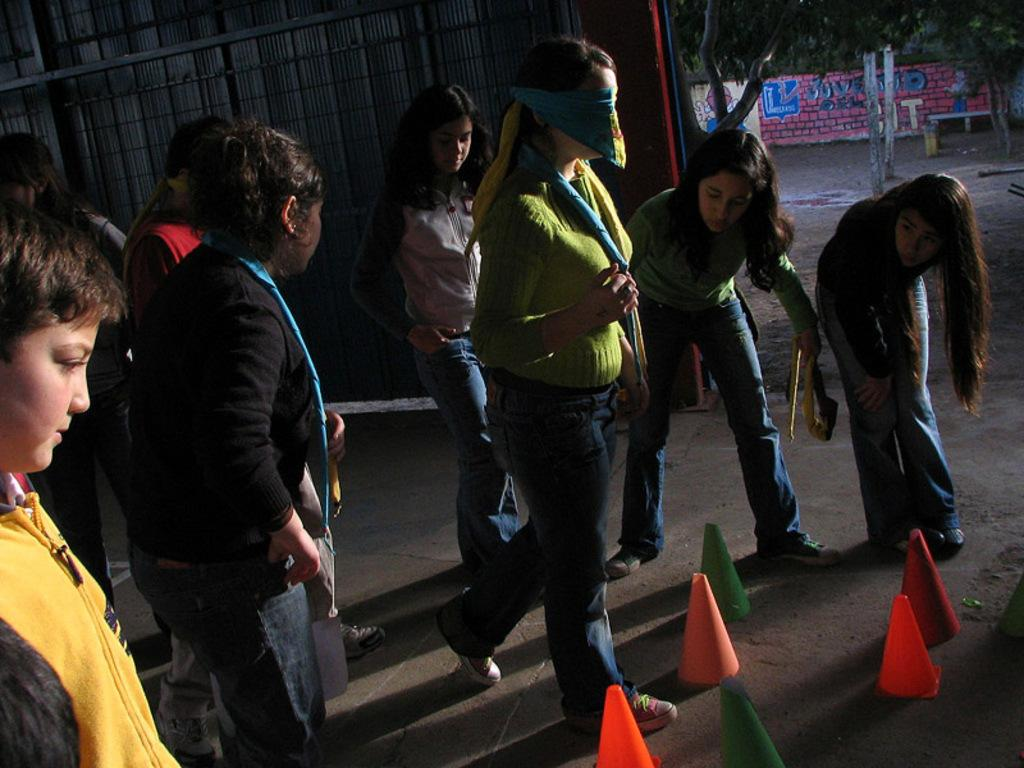How many women are in the image? There are women standing in the image. Can you describe any specific details about the women be observed? One of the women is blindfolded. What can be seen in the background of the image? There are trees, walls with paintings, and mesh gates in the background of the image. What arithmetic problem is the blindfolded woman trying to solve in the image? There is no arithmetic problem present in the image; the blindfolded woman is not engaged in any such activity. What type of flesh is visible on the mesh gates in the image? There is no flesh visible on the mesh gates in the image; they are made of metal or another material. 